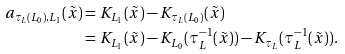<formula> <loc_0><loc_0><loc_500><loc_500>a _ { \tau _ { L } ( L _ { 0 } ) , L _ { 1 } } ( \tilde { x } ) & = K _ { L _ { 1 } } ( \tilde { x } ) - K _ { \tau _ { L } ( L _ { 0 } ) } ( \tilde { x } ) \\ & = K _ { L _ { 1 } } ( \tilde { x } ) - K _ { L _ { 0 } } ( \tau _ { L } ^ { - 1 } ( \tilde { x } ) ) - K _ { \tau _ { L } } ( \tau _ { L } ^ { - 1 } ( \tilde { x } ) ) .</formula> 